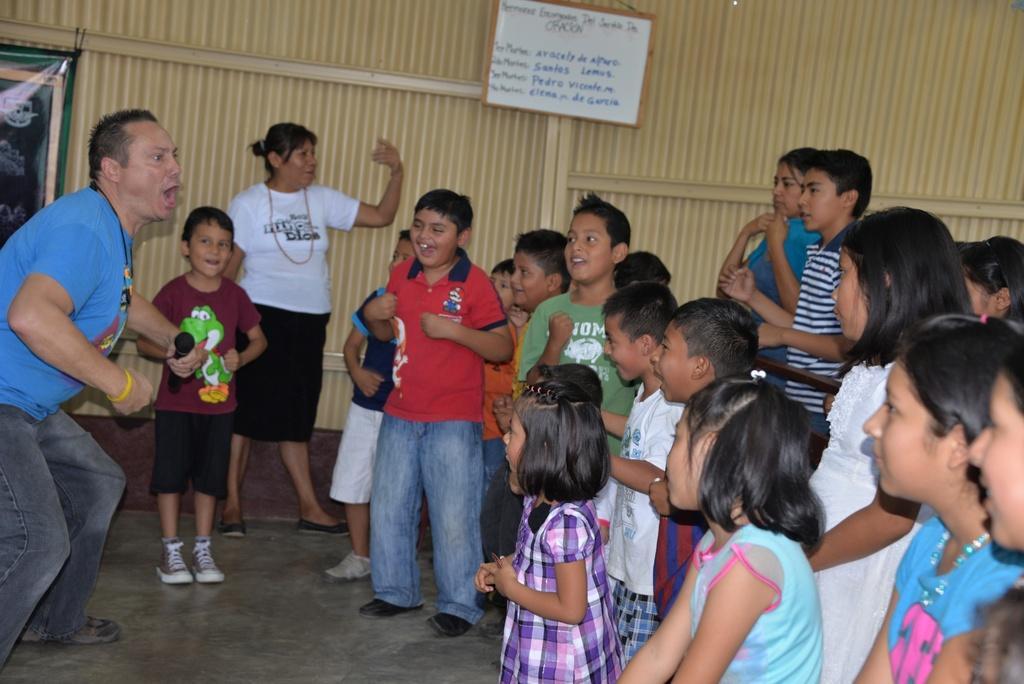Can you describe this image briefly? In this picture we can see group of people, at the top of the image we can see a board on the wall, on the left side of the image we can see a banner. 